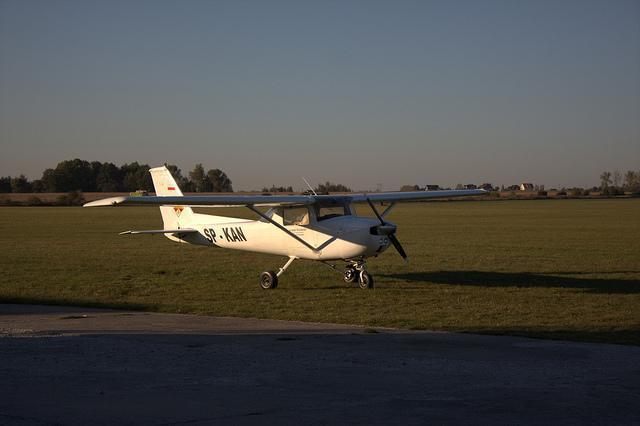How many wheels does the plane have?
Give a very brief answer. 3. How many windows does the plane have excluding the pilot area?
Give a very brief answer. 0. How many propeller blades are there all together?
Give a very brief answer. 2. How many towers can be seen?
Give a very brief answer. 0. How many airlines are represented in this image?
Give a very brief answer. 1. How many people in the front row are smiling?
Give a very brief answer. 0. 